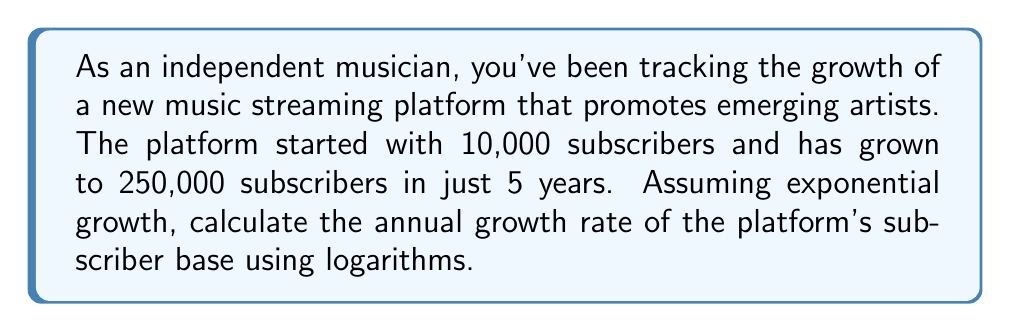Could you help me with this problem? Let's approach this step-by-step using the exponential growth formula and logarithms:

1) The exponential growth formula is:
   $A = P(1+r)^t$
   Where:
   $A$ = final amount (250,000 subscribers)
   $P$ = initial amount (10,000 subscribers)
   $r$ = annual growth rate (what we're solving for)
   $t$ = time in years (5 years)

2) Plug in the known values:
   $250,000 = 10,000(1+r)^5$

3) Divide both sides by 10,000:
   $25 = (1+r)^5$

4) Take the natural logarithm of both sides:
   $\ln(25) = \ln((1+r)^5)$

5) Use the logarithm property $\ln(x^n) = n\ln(x)$:
   $\ln(25) = 5\ln(1+r)$

6) Divide both sides by 5:
   $\frac{\ln(25)}{5} = \ln(1+r)$

7) Take $e$ to the power of both sides:
   $e^{\frac{\ln(25)}{5}} = e^{\ln(1+r)}$

8) Simplify the right side (as $e^{\ln(x)} = x$):
   $e^{\frac{\ln(25)}{5}} = 1+r$

9) Subtract 1 from both sides:
   $e^{\frac{\ln(25)}{5}} - 1 = r$

10) Calculate the value:
    $r \approx 0.2009$ or about 20.09%
Answer: $20.09\%$ 